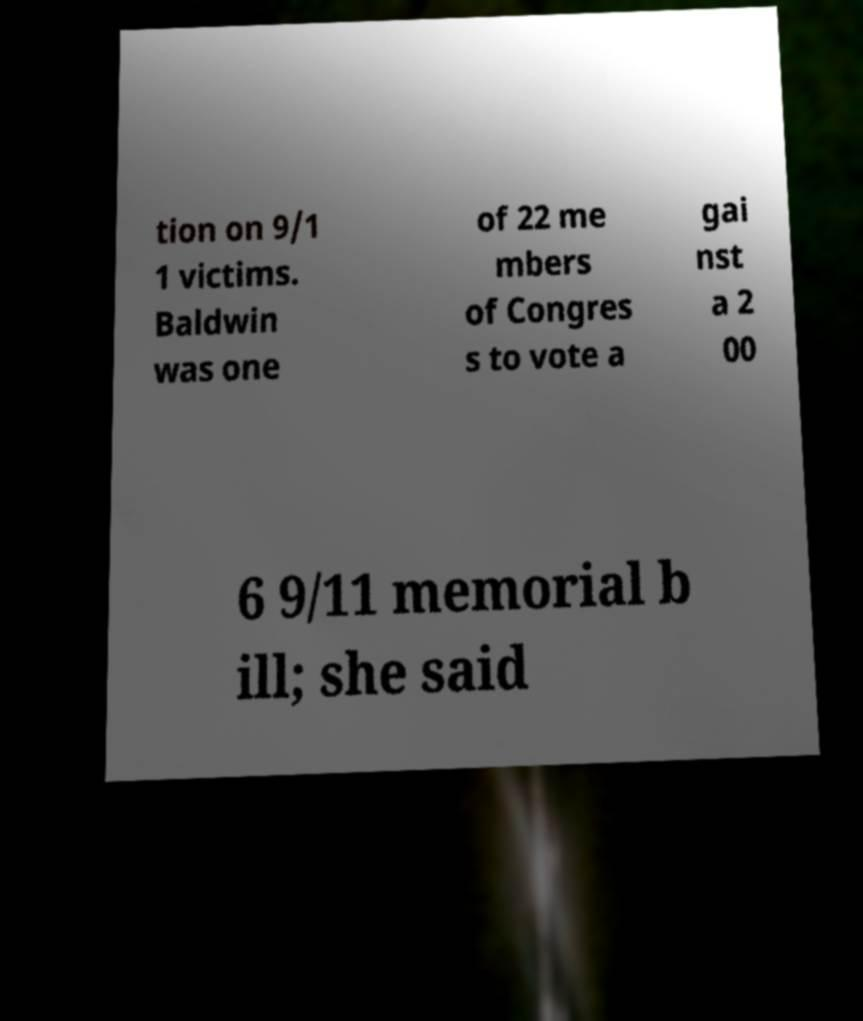Could you assist in decoding the text presented in this image and type it out clearly? tion on 9/1 1 victims. Baldwin was one of 22 me mbers of Congres s to vote a gai nst a 2 00 6 9/11 memorial b ill; she said 